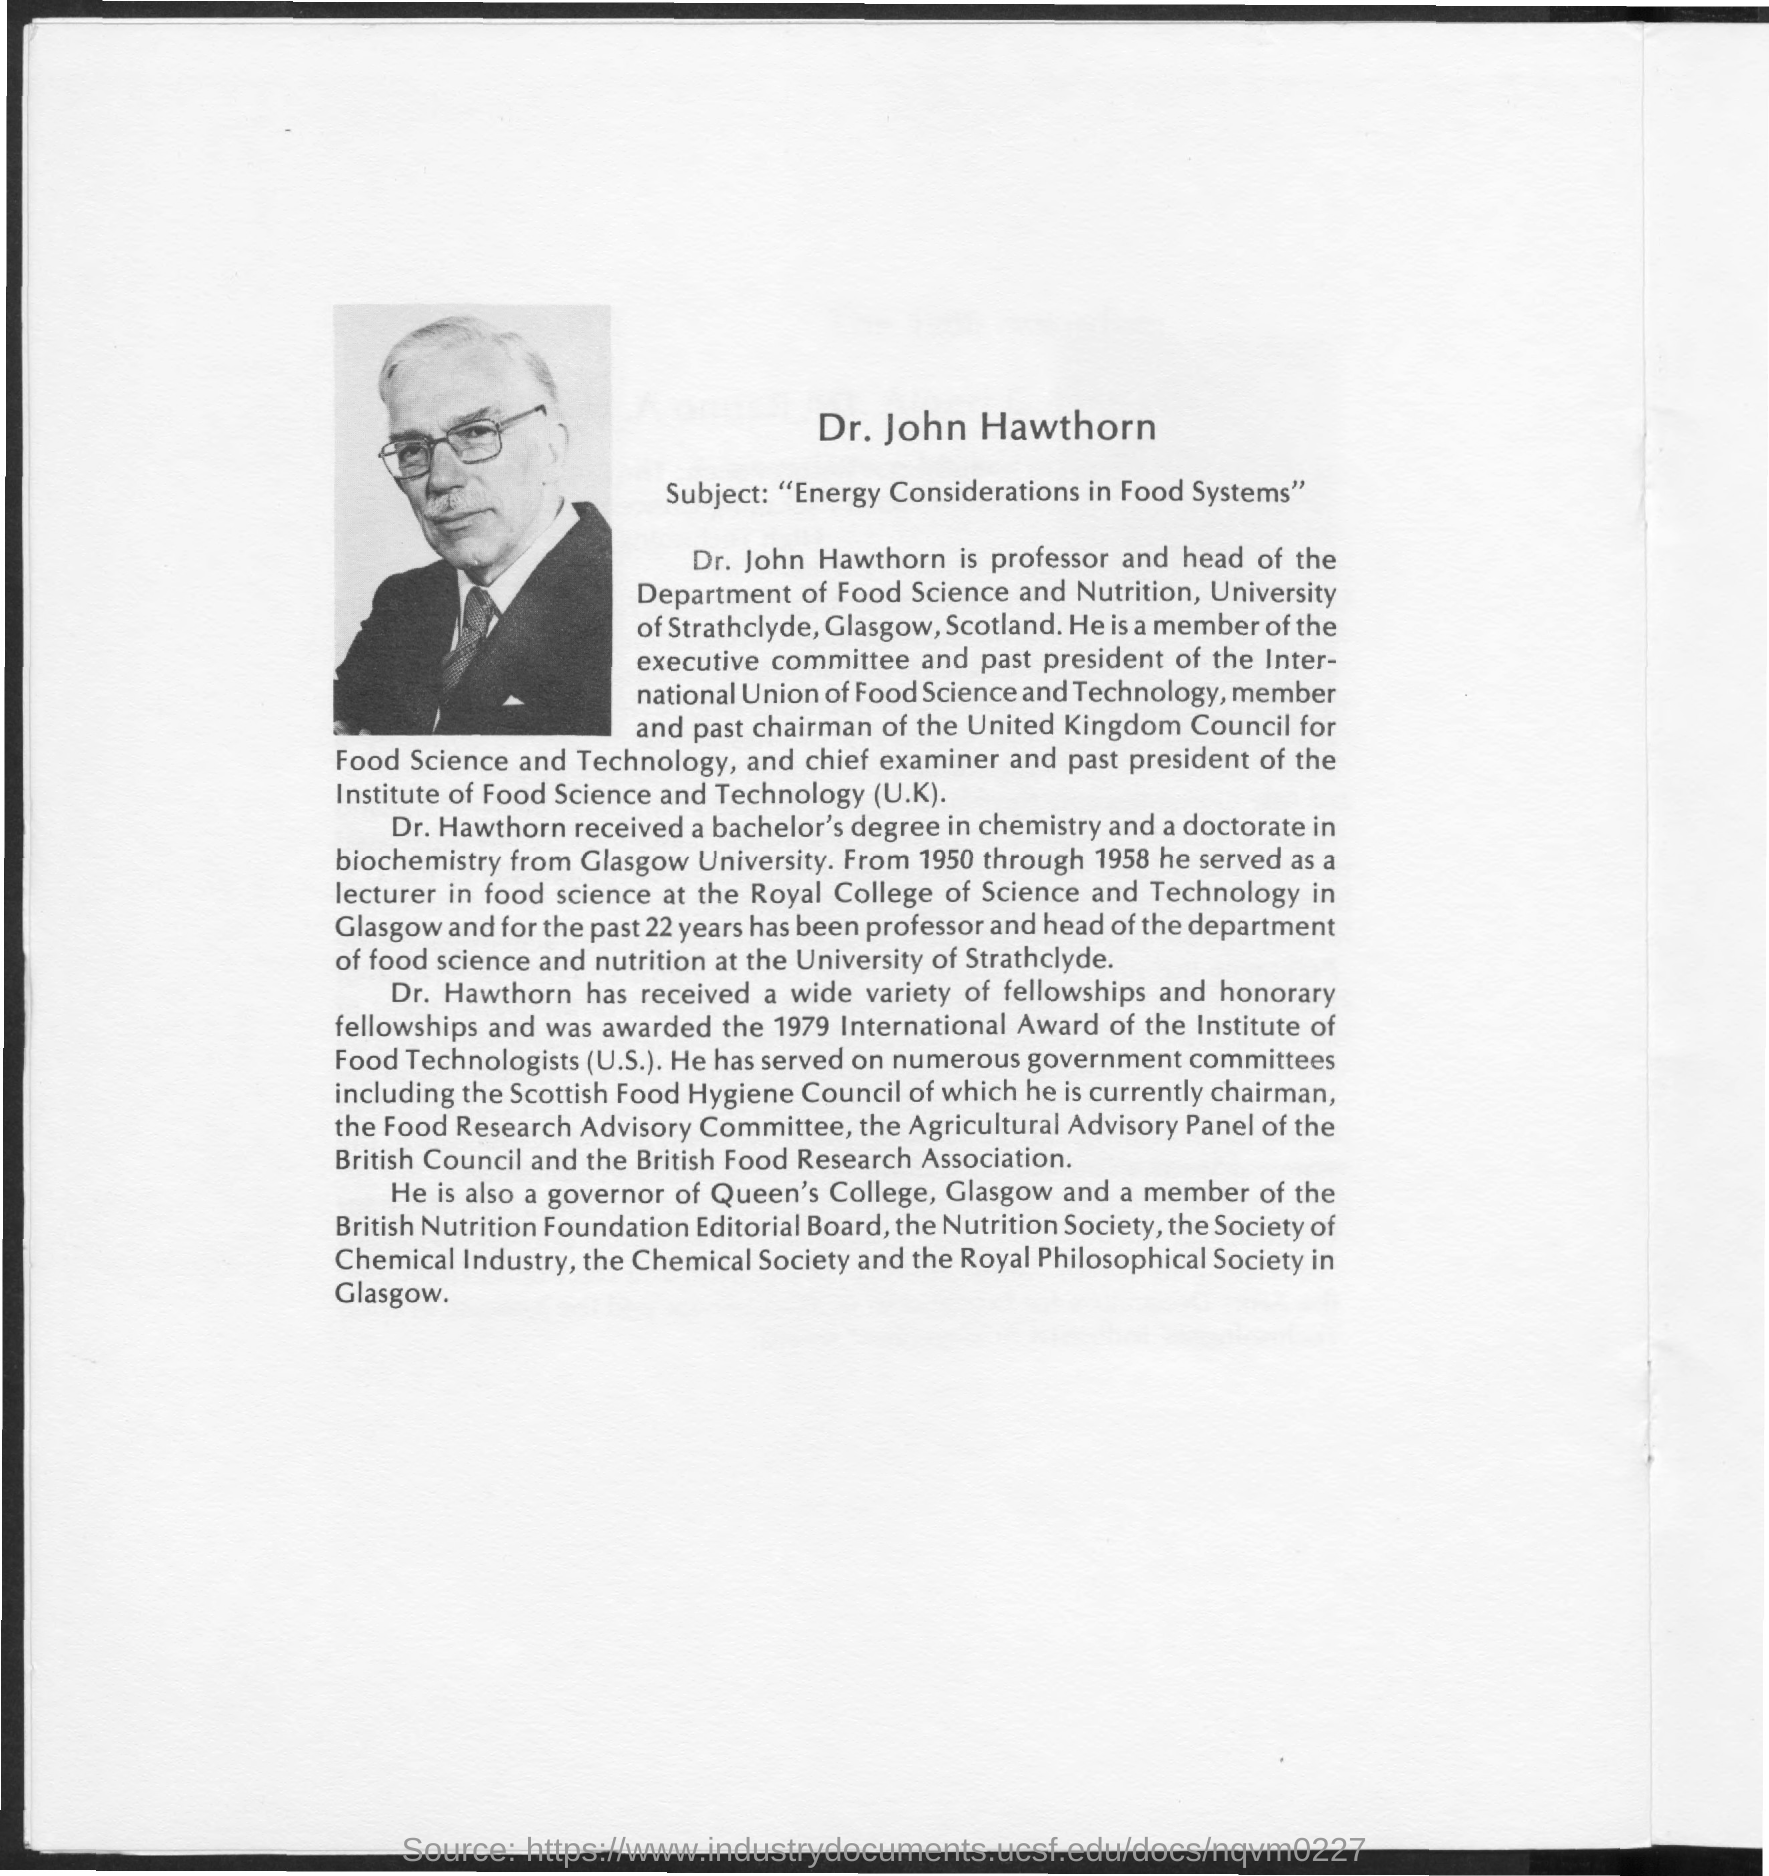Who is mentioned in the write up?
Offer a very short reply. Dr. Hawthorn. What is the subject of Dr. John?
Make the answer very short. Energy Considerations in Food Systems. From which university did Dr. Hawthorn receive bachelor's degree and doctorate?
Your answer should be very brief. Glasgow University. Which council is Dr. Hawthorn currently the chairman of?
Make the answer very short. The scottish food hygiene council. 